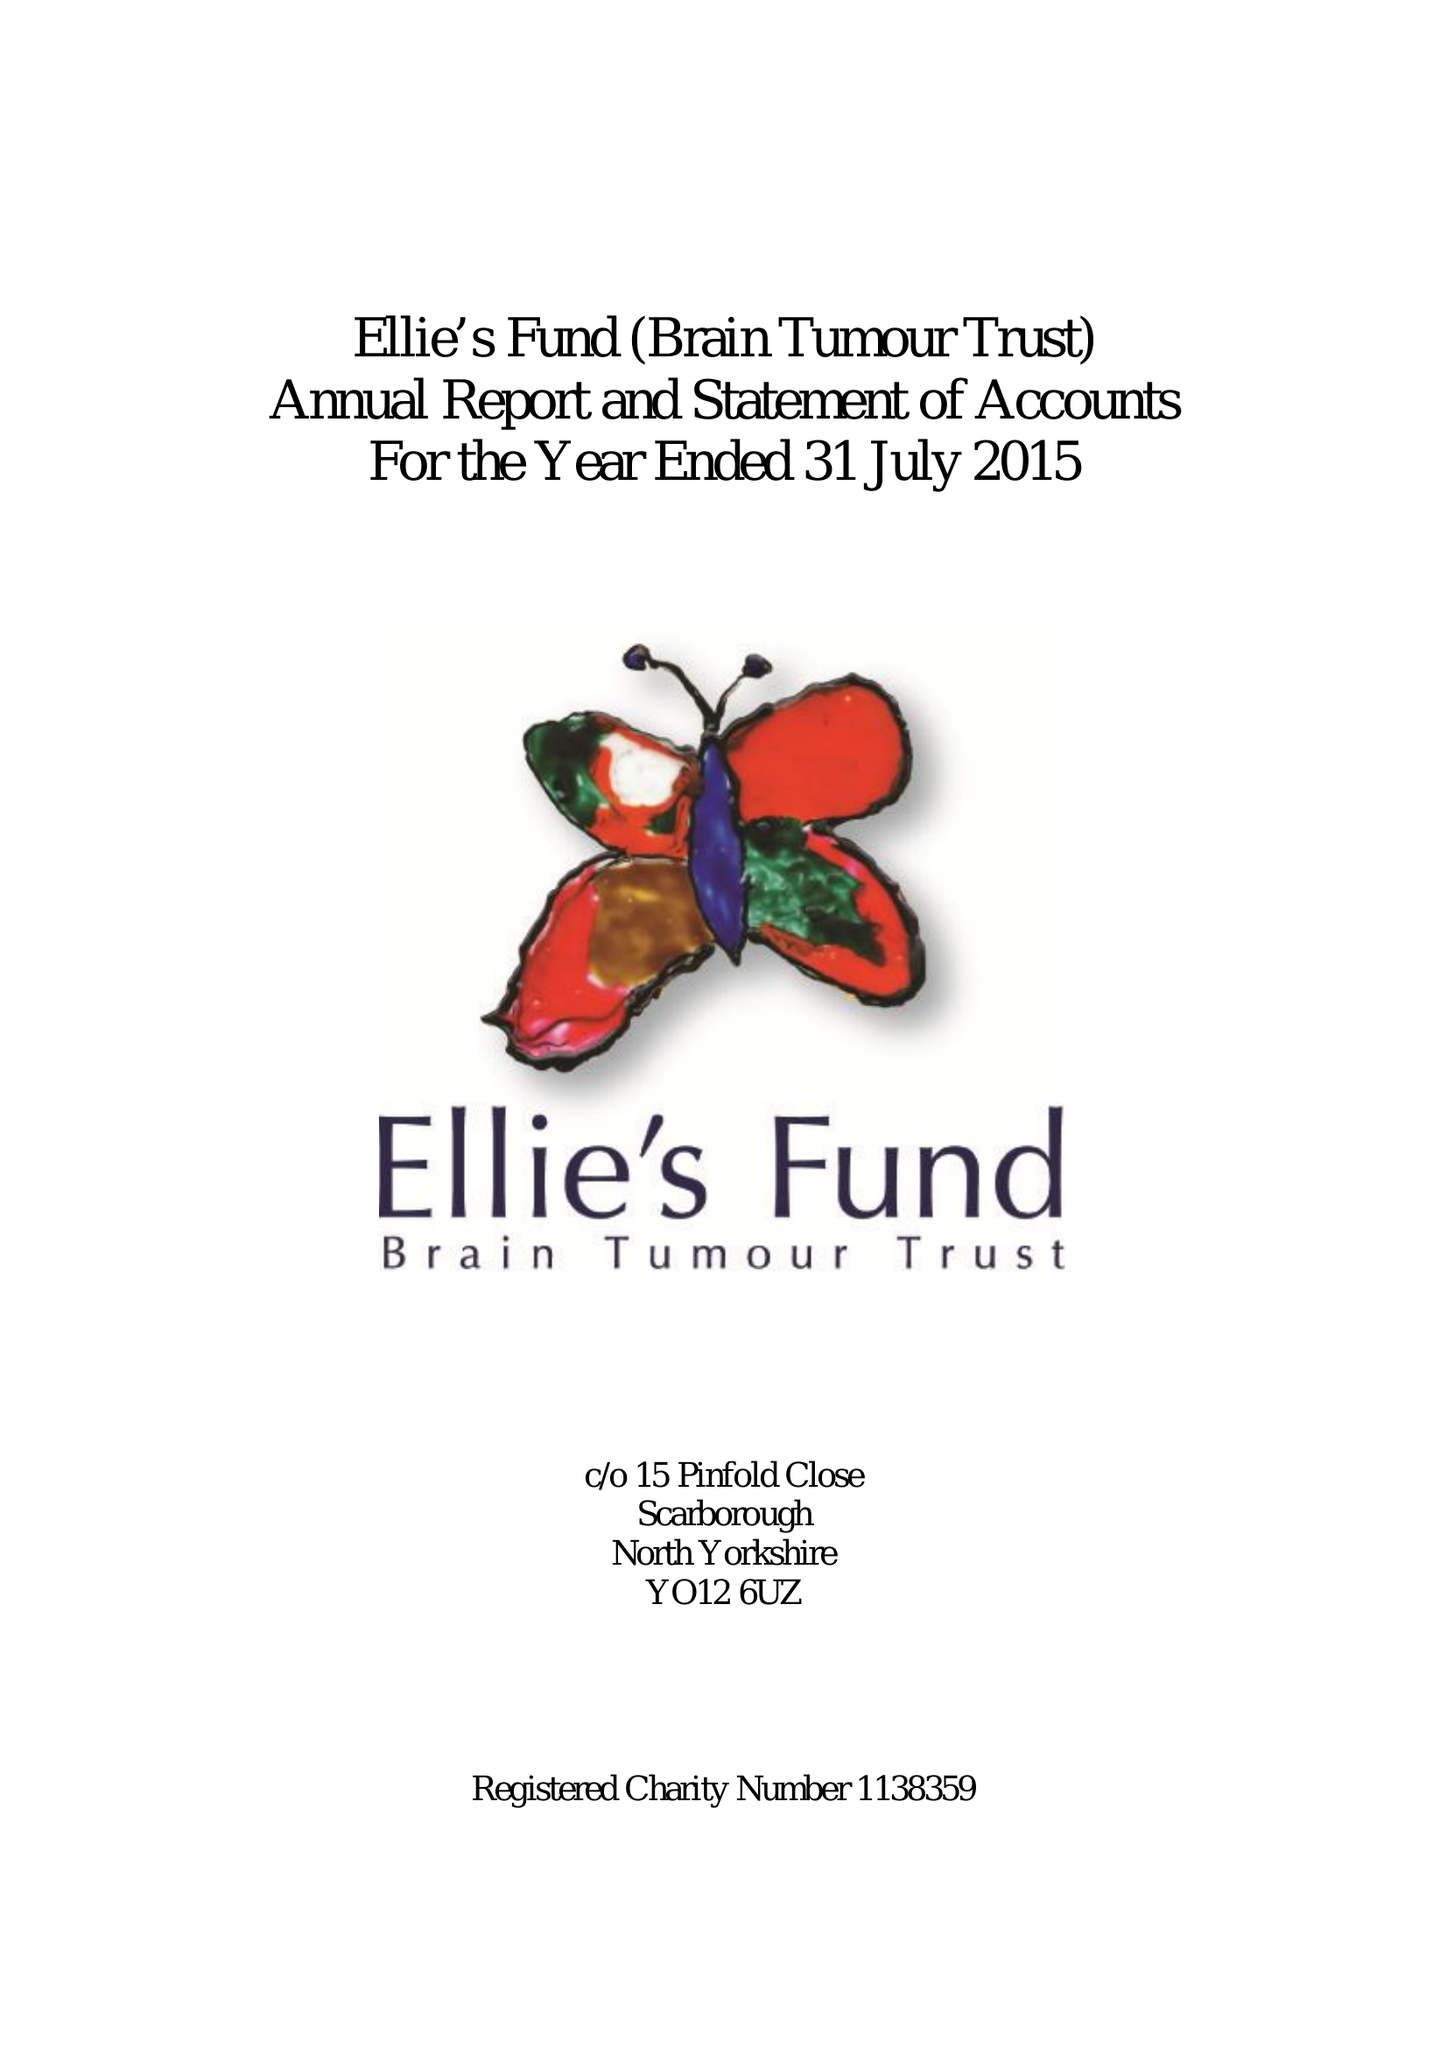What is the value for the charity_name?
Answer the question using a single word or phrase. Ellie's Fund (Brain Tumour Trust) 